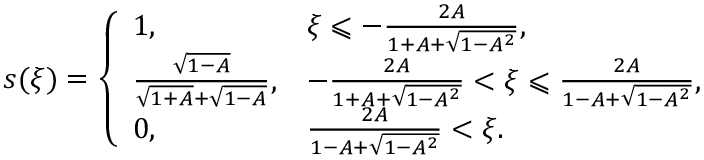<formula> <loc_0><loc_0><loc_500><loc_500>s ( \xi ) = \left \{ \begin{array} { l l } { 1 , } & { \xi \leqslant - \frac { 2 A } { 1 + A + \sqrt { 1 - A ^ { 2 } } } , } \\ { \frac { \sqrt { 1 - A } } { \sqrt { 1 + A } + \sqrt { 1 - A } } , } & { - \frac { 2 A } { 1 + A + \sqrt { 1 - A ^ { 2 } } } < \xi \leqslant \frac { 2 A } { 1 - A + \sqrt { 1 - A ^ { 2 } } } , } \\ { 0 , } & { \frac { 2 A } { 1 - A + \sqrt { 1 - A ^ { 2 } } } < \xi . } \end{array}</formula> 